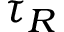Convert formula to latex. <formula><loc_0><loc_0><loc_500><loc_500>\tau _ { R }</formula> 